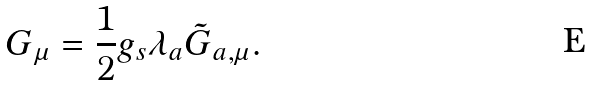Convert formula to latex. <formula><loc_0><loc_0><loc_500><loc_500>G _ { \mu } = \frac { 1 } { 2 } g _ { s } \lambda _ { a } \tilde { G } _ { a , \mu } .</formula> 